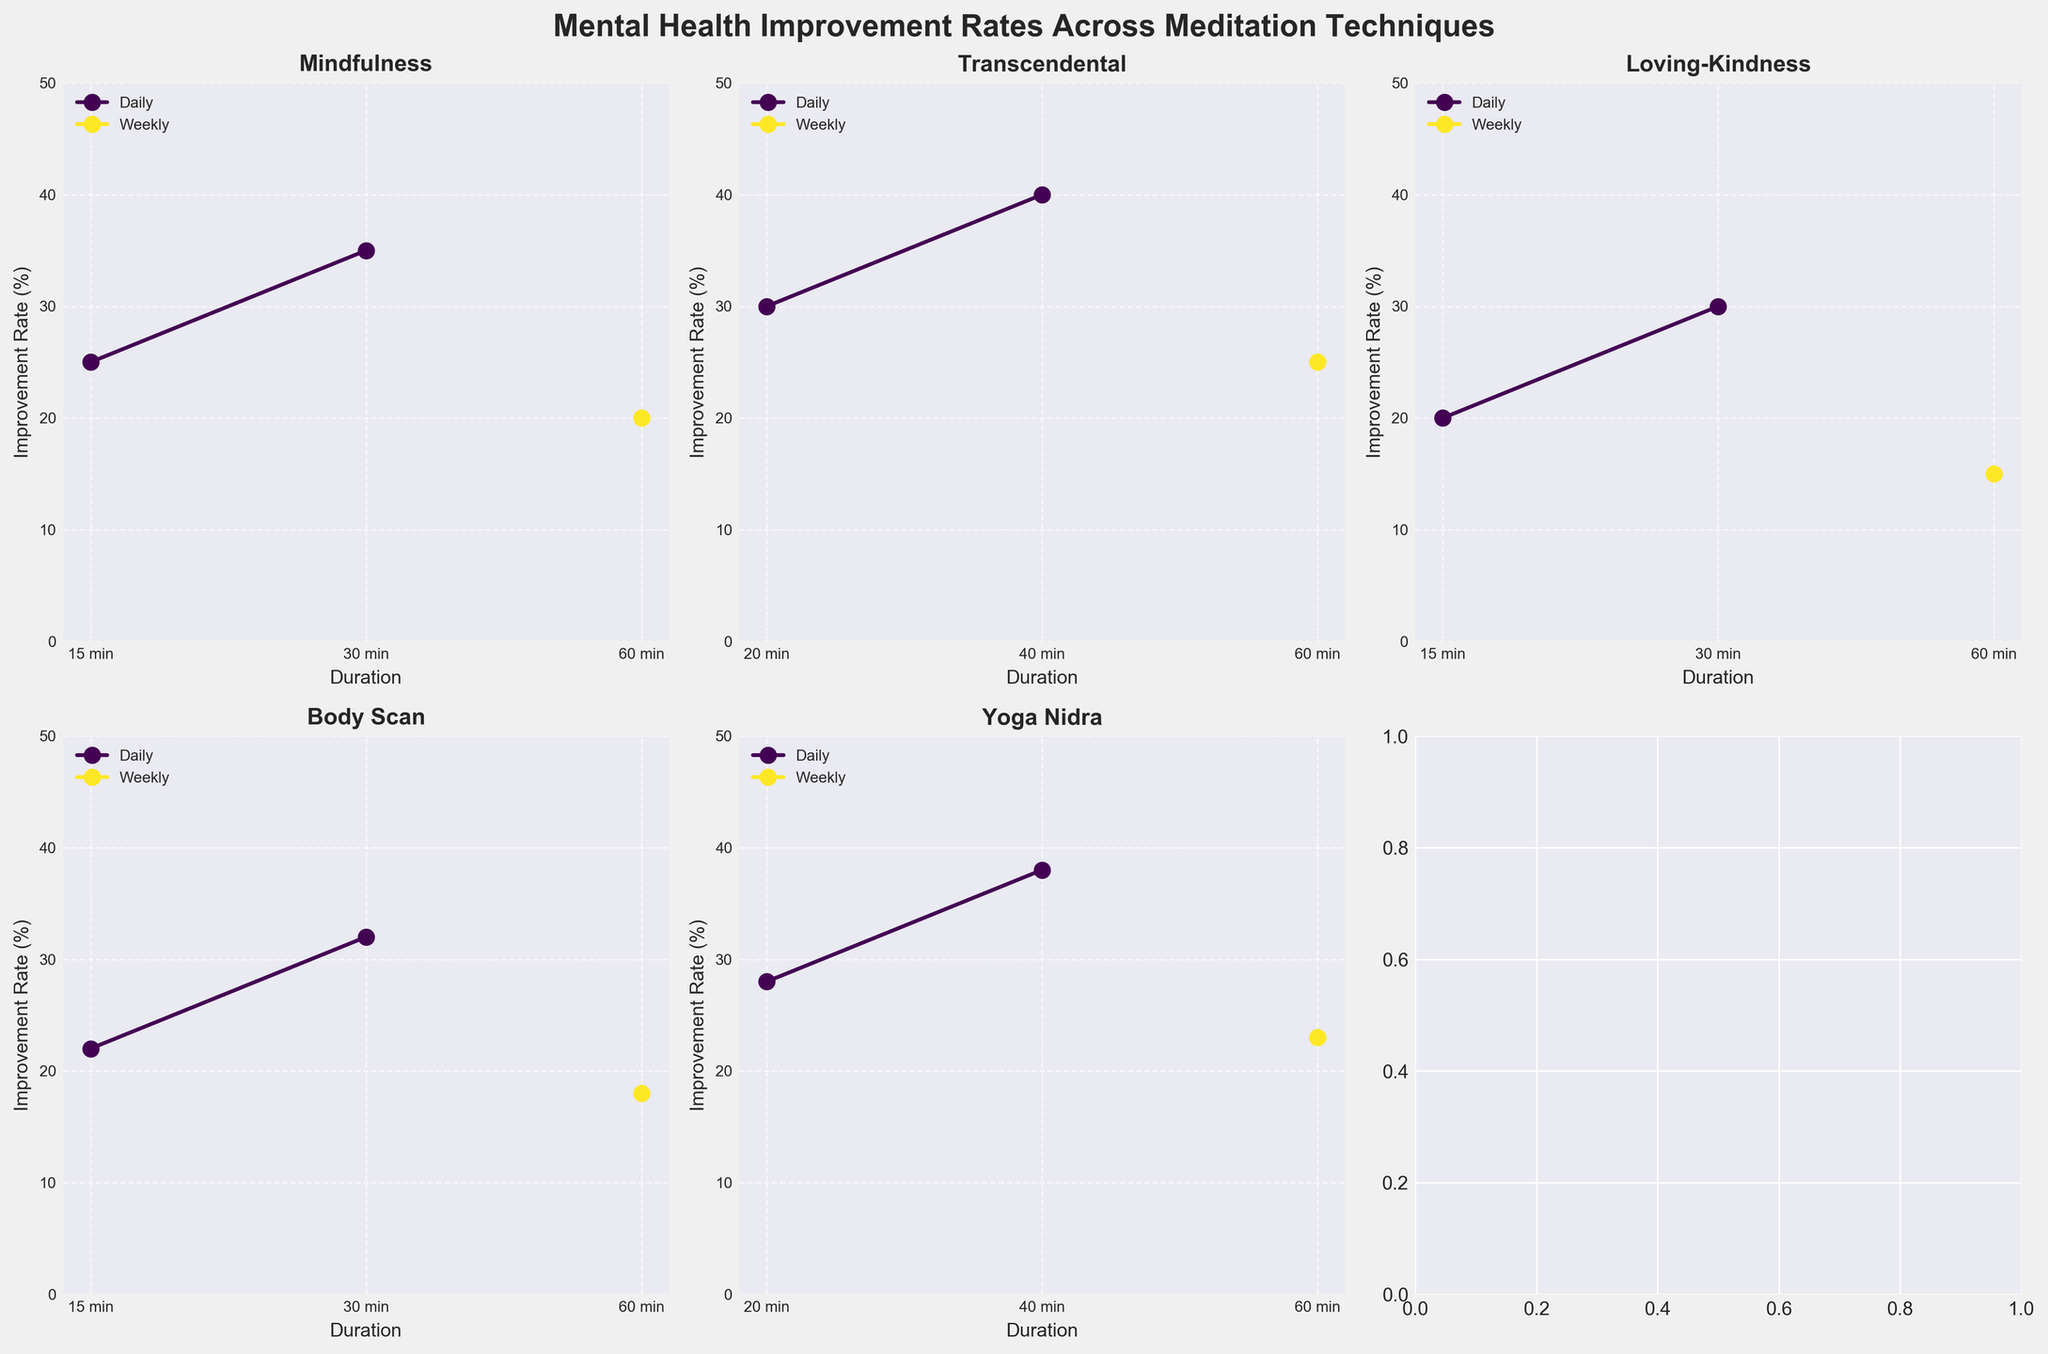What is the title of the figure? The title of the figure is displayed at the top of the plot in a large and bold font.
Answer: Mental Health Improvement Rates Across Meditation Techniques Which meditation technique has the highest improvement rate for a daily practice of 40 minutes? Find the subplot titled 'Yoga Nidra' and find the data point corresponding to 'Daily' at 40 minutes. This technique shows the highest rate among others.
Answer: Yoga Nidra How does the improvement rate for weekly sessions of 60 minutes compare across techniques? Compare the data points marked 'Weekly' at 60 minutes across all subplots. Mindfulness: 20, Transcendental: 25, Loving-Kindness: 15, Body Scan: 18, Yoga Nidra: 23.
Answer: Transcendental > Yoga Nidra > Mindfulness > Body Scan > Loving-Kindness What's the difference in improvement rates between daily practices of 15 minutes and 30 minutes for Loving-Kindness? Locate the Loving-Kindness subplot. The improvement rates for daily 15 minutes is 20% and for 30 minutes is 30%. Calculate 30 - 20.
Answer: 10% Which technique shows the most significant increase in improvement rate as the duration increases for daily practice? Observe each subplot and compare the difference between improvement rates in daily practice as duration increases the most notable increase is from 30% to 40% for Transcendental from 20 to 40 minutes.
Answer: Transcendental Which duration shows the highest improvement rate for Body Scan when practicing daily? In the Body Scan subplot, find the daily practice data points. The highest rate is for 30 minutes with a rate of 32%.
Answer: 30 minutes Are there any meditation techniques that show a higher improvement rate with a weekly practice compared to a daily practice? Compare the weekly and daily groups within each subplot. No technique shows higher improvement rates with weekly practice compared to daily practice.
Answer: No What’s the average improvement rate for daily 30-minute practices across all techniques? Find the daily 30-minute data points in each subplot and compute the average (35 + 30 + 32 + 30 + 38)/5 = 33%.
Answer: 33% Which frequency and duration combination yields the lowest improvement rate for any technique? Find the lowest improvement rate across all subplots which is for Loving-Kindness, weekly at 60 minutes showing 15%.
Answer: Weekly, 60 minutes, Loving-Kindness How do improvement rates for daily 20-minute practices compare between Transcendental and Yoga Nidra? Locate the daily 20-minute data points in the subplots for both techniques. Transcendental shows 30%, whereas Yoga Nidra shows 28%.
Answer: Transcendental > Yoga Nidra 